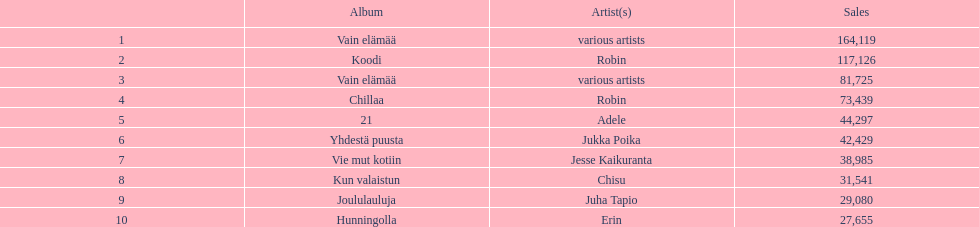What is the total number of sales for the top 10 albums? 650396. 